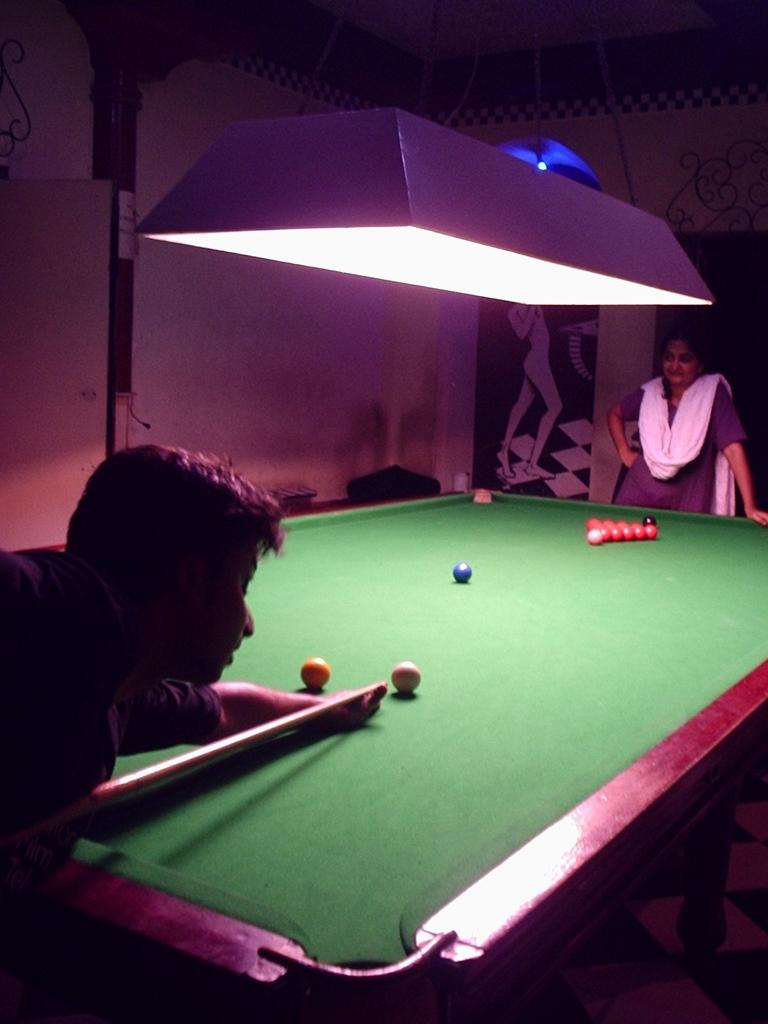What is happening at one end of the snookers table in the image? There is a woman standing at one end of the snookers table. What is the person at the other end of the table doing? The person is hitting a ball on the snookers table. What can be seen in the background of the image? There are posters and a light visible in the background. What type of marble is used to make the snookers table in the image? There is no information about the material used to make the snookers table in the image. Can you tell me how many buttons are on the woman's shirt in the image? There is no information about the woman's shirt or the presence of buttons in the image. 